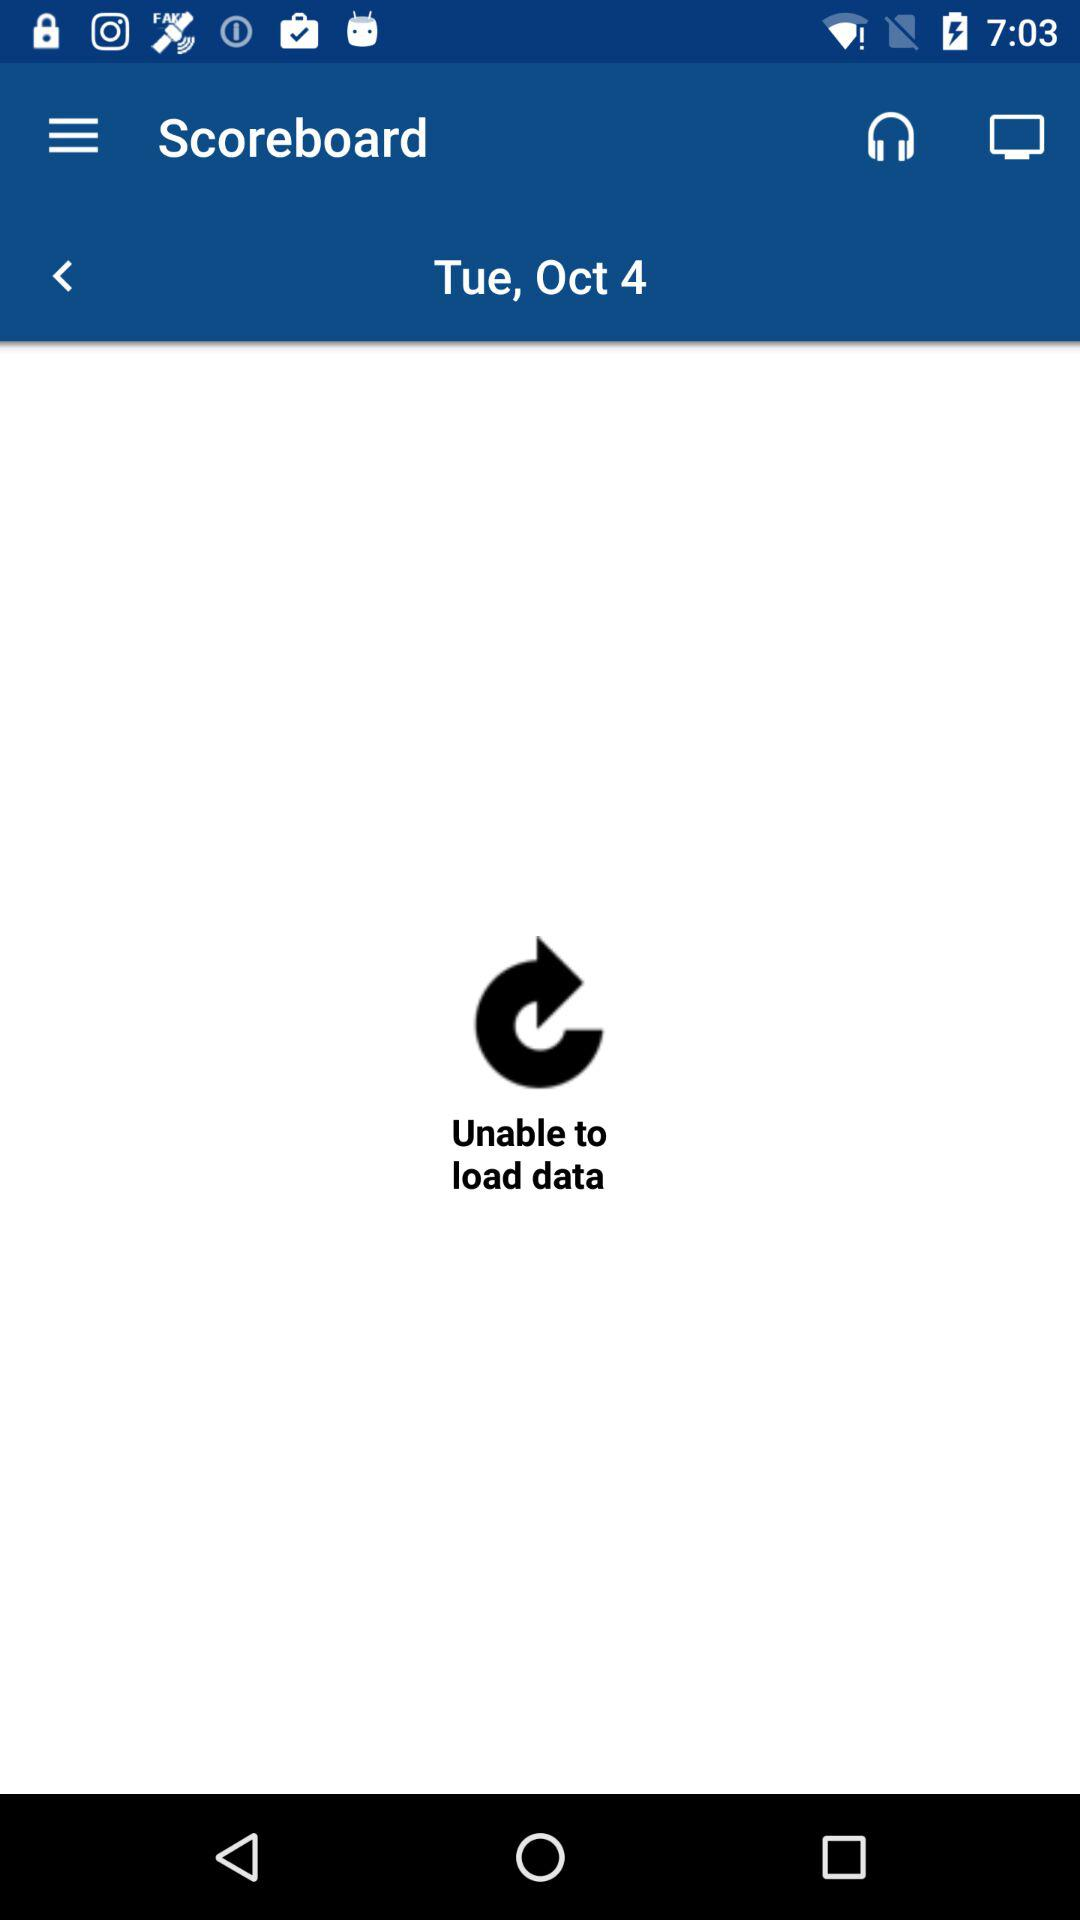What is the date? The date is Tuesday, October 4. 